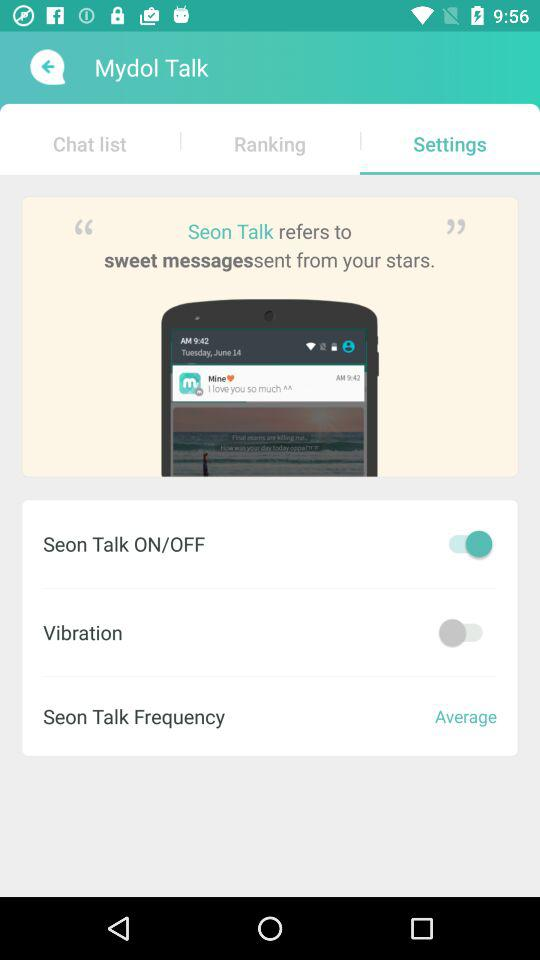What is the application name? The application name is "Mydol Talk". 